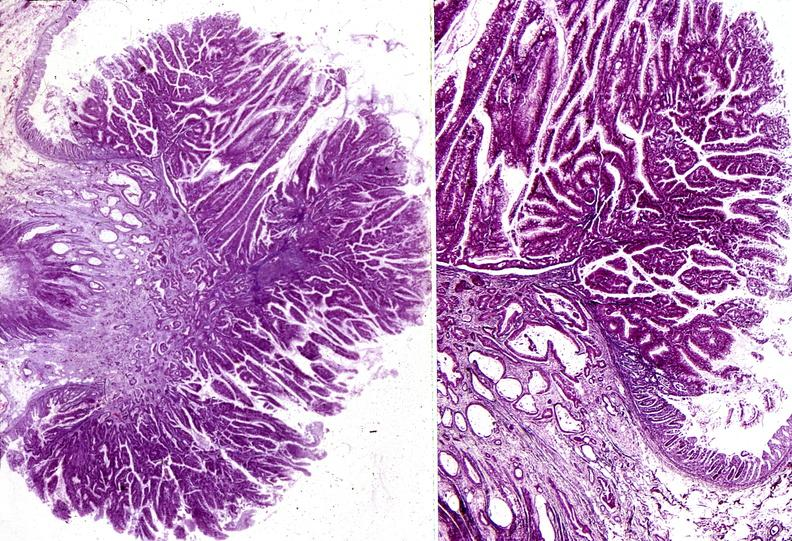does this image show colon, villous polyp and adenocarcinoma?
Answer the question using a single word or phrase. Yes 